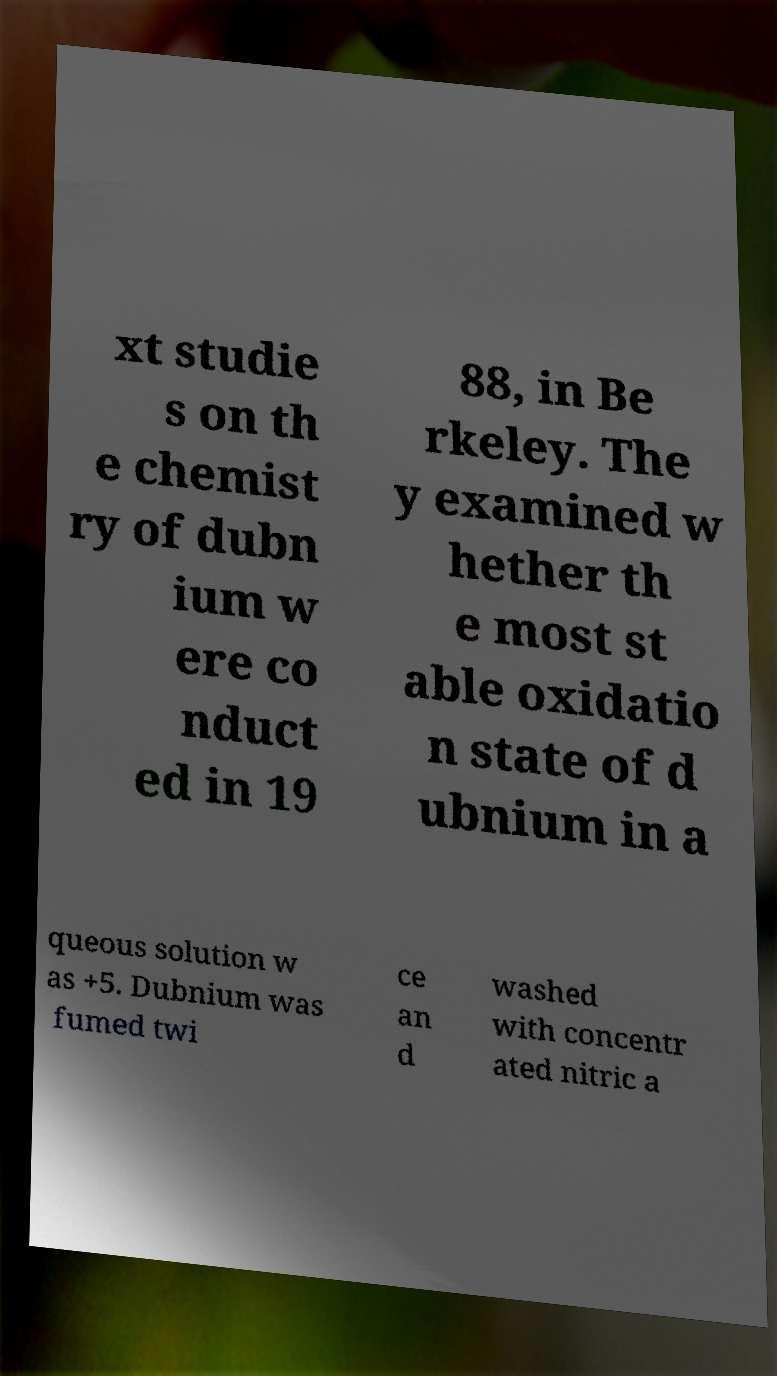Please identify and transcribe the text found in this image. xt studie s on th e chemist ry of dubn ium w ere co nduct ed in 19 88, in Be rkeley. The y examined w hether th e most st able oxidatio n state of d ubnium in a queous solution w as +5. Dubnium was fumed twi ce an d washed with concentr ated nitric a 